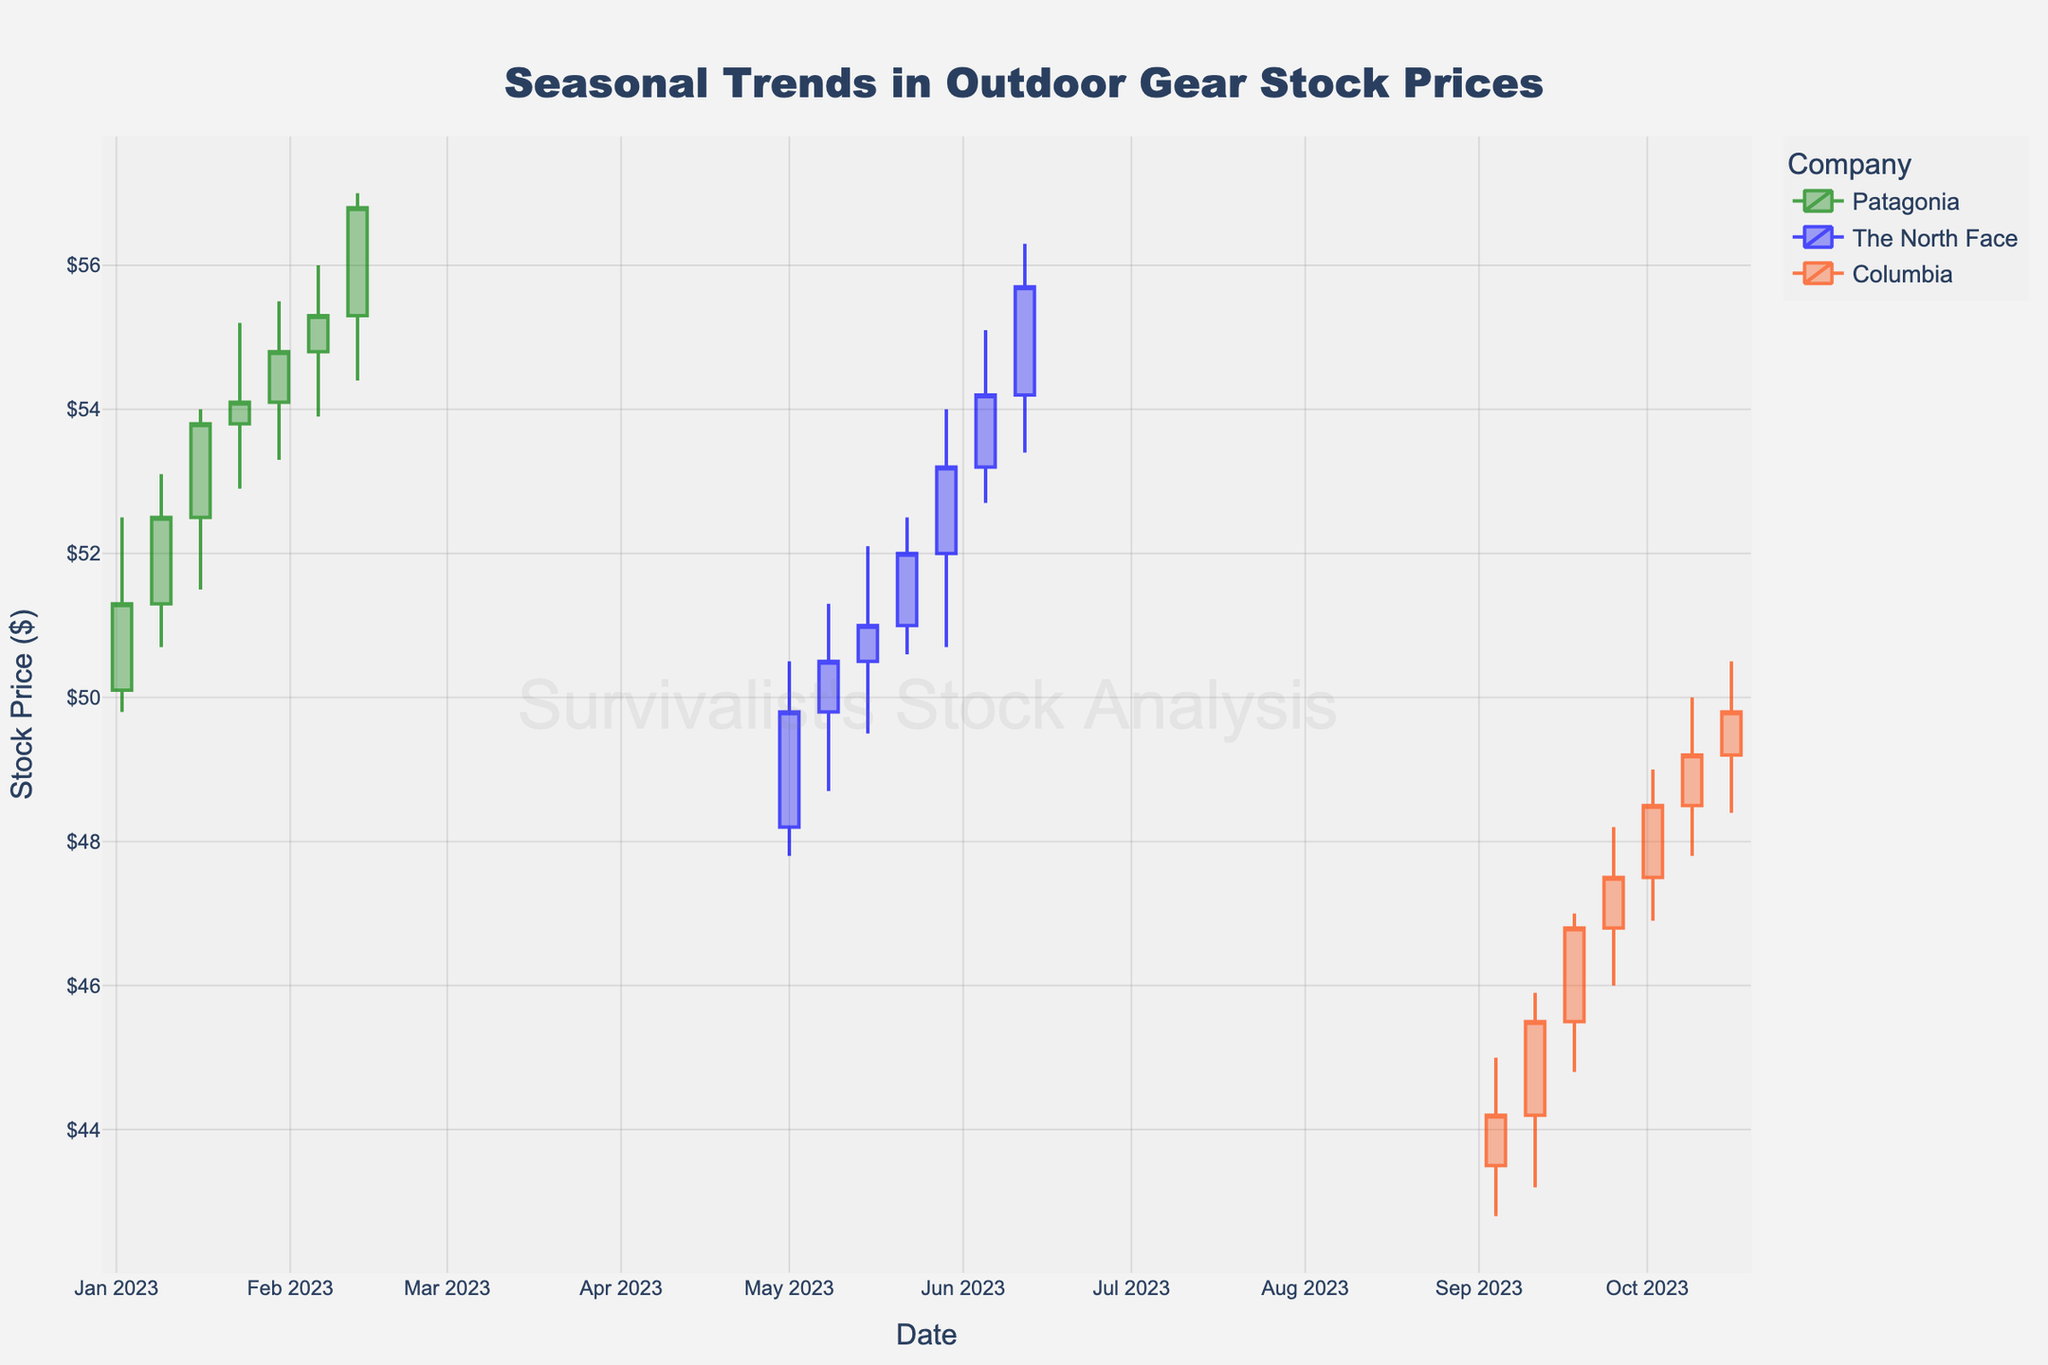What is the title of the plot? The title is typically prominently displayed at the top of the chart. It provides an overview of what the visual data represents.
Answer: Seasonal Trends in Outdoor Gear Stock Prices Which company had the highest stock price in January 2023? The figure shows candlestick plots for different companies over time. By looking at January 2023, we observe that Patagonia's stock reached the highest point, compared to the other companies listed in that period.
Answer: Patagonia How many companies' stock prices are shown in the figure? The legend on the chart indicates the different companies represented. Each has a distinct color associated with their data plots.
Answer: Three What is the trend in The North Face's stock price from May 1, 2023, to June 12, 2023? Observing the series of candlestick plots for The North Face, starting from May 1, 2023, we see a general upward trend where the stock price increases almost every week.
Answer: Increasing trend Which company had the lowest stock price in September 2023? By checking the candlestick plots for September 2023, we observe the lowest price points for each company and identify the lowest one.
Answer: Columbia Compare the stock price of Columbia between September and October 2023. By comparing the prices in the respective time frames, we can see that Columbia's stock price generally increased from September to October 2023, as indicated by the candlestick plots for those periods.
Answer: Increased During which month did Patagonia's stock price see the highest increase in 2023? Comparing the opening and closing prices across different months, January shows a noticeable increase in stock prices for Patagonia, especially from the start to the end of the month.
Answer: January What was the volume traded for Patagonia on February 13, 2023? Each candlestick plot typically includes volume information, shown either directly or through an associated bar plot. Here, we find that on February 13, 2023, Patagonia had a trading volume of 600,000.
Answer: 600,000 Which company exhibited the most stable stock prices over the observed periods? Stability can be inferred from viewing the lengths of the candlesticks. Short candlesticks with minimal fluctuation indicate stability.
Answer: The North Face In which month did The North Face start experiencing a steady increase in stock price in 2023? By observing The North Face's stock price trajectory, the steady increase began in May 2023 and continued through June.
Answer: May 